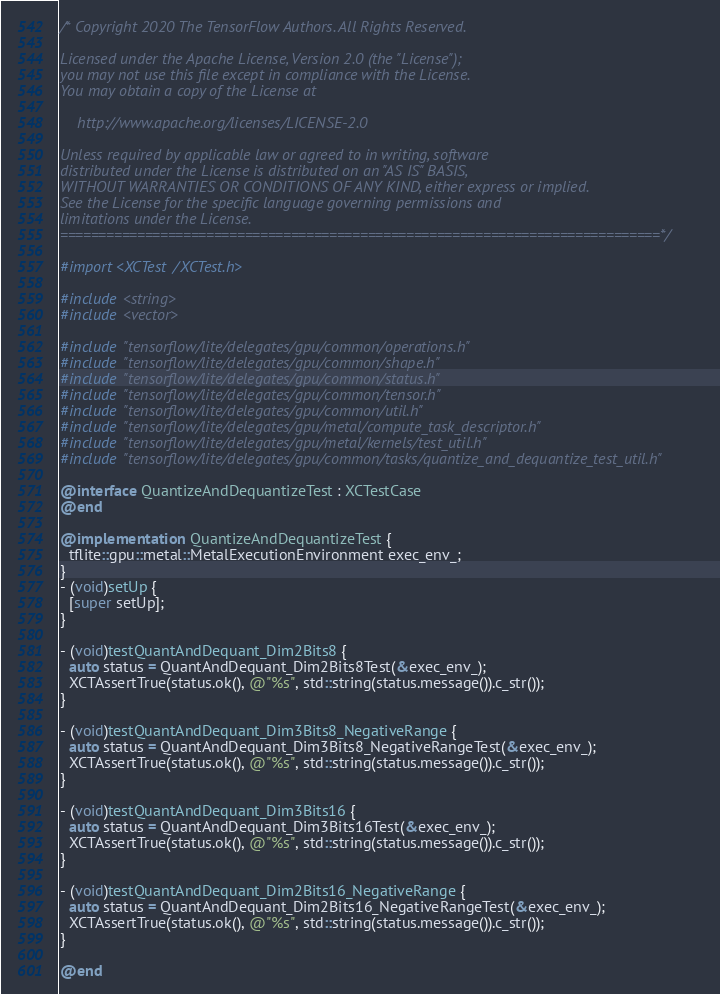<code> <loc_0><loc_0><loc_500><loc_500><_ObjectiveC_>/* Copyright 2020 The TensorFlow Authors. All Rights Reserved.

Licensed under the Apache License, Version 2.0 (the "License");
you may not use this file except in compliance with the License.
You may obtain a copy of the License at

    http://www.apache.org/licenses/LICENSE-2.0

Unless required by applicable law or agreed to in writing, software
distributed under the License is distributed on an "AS IS" BASIS,
WITHOUT WARRANTIES OR CONDITIONS OF ANY KIND, either express or implied.
See the License for the specific language governing permissions and
limitations under the License.
==============================================================================*/

#import <XCTest/XCTest.h>

#include <string>
#include <vector>

#include "tensorflow/lite/delegates/gpu/common/operations.h"
#include "tensorflow/lite/delegates/gpu/common/shape.h"
#include "tensorflow/lite/delegates/gpu/common/status.h"
#include "tensorflow/lite/delegates/gpu/common/tensor.h"
#include "tensorflow/lite/delegates/gpu/common/util.h"
#include "tensorflow/lite/delegates/gpu/metal/compute_task_descriptor.h"
#include "tensorflow/lite/delegates/gpu/metal/kernels/test_util.h"
#include "tensorflow/lite/delegates/gpu/common/tasks/quantize_and_dequantize_test_util.h"

@interface QuantizeAndDequantizeTest : XCTestCase
@end

@implementation QuantizeAndDequantizeTest {
  tflite::gpu::metal::MetalExecutionEnvironment exec_env_;
}
- (void)setUp {
  [super setUp];
}

- (void)testQuantAndDequant_Dim2Bits8 {
  auto status = QuantAndDequant_Dim2Bits8Test(&exec_env_);
  XCTAssertTrue(status.ok(), @"%s", std::string(status.message()).c_str());
}

- (void)testQuantAndDequant_Dim3Bits8_NegativeRange {
  auto status = QuantAndDequant_Dim3Bits8_NegativeRangeTest(&exec_env_);
  XCTAssertTrue(status.ok(), @"%s", std::string(status.message()).c_str());
}

- (void)testQuantAndDequant_Dim3Bits16 {
  auto status = QuantAndDequant_Dim3Bits16Test(&exec_env_);
  XCTAssertTrue(status.ok(), @"%s", std::string(status.message()).c_str());
}

- (void)testQuantAndDequant_Dim2Bits16_NegativeRange {
  auto status = QuantAndDequant_Dim2Bits16_NegativeRangeTest(&exec_env_);
  XCTAssertTrue(status.ok(), @"%s", std::string(status.message()).c_str());
}

@end
</code> 